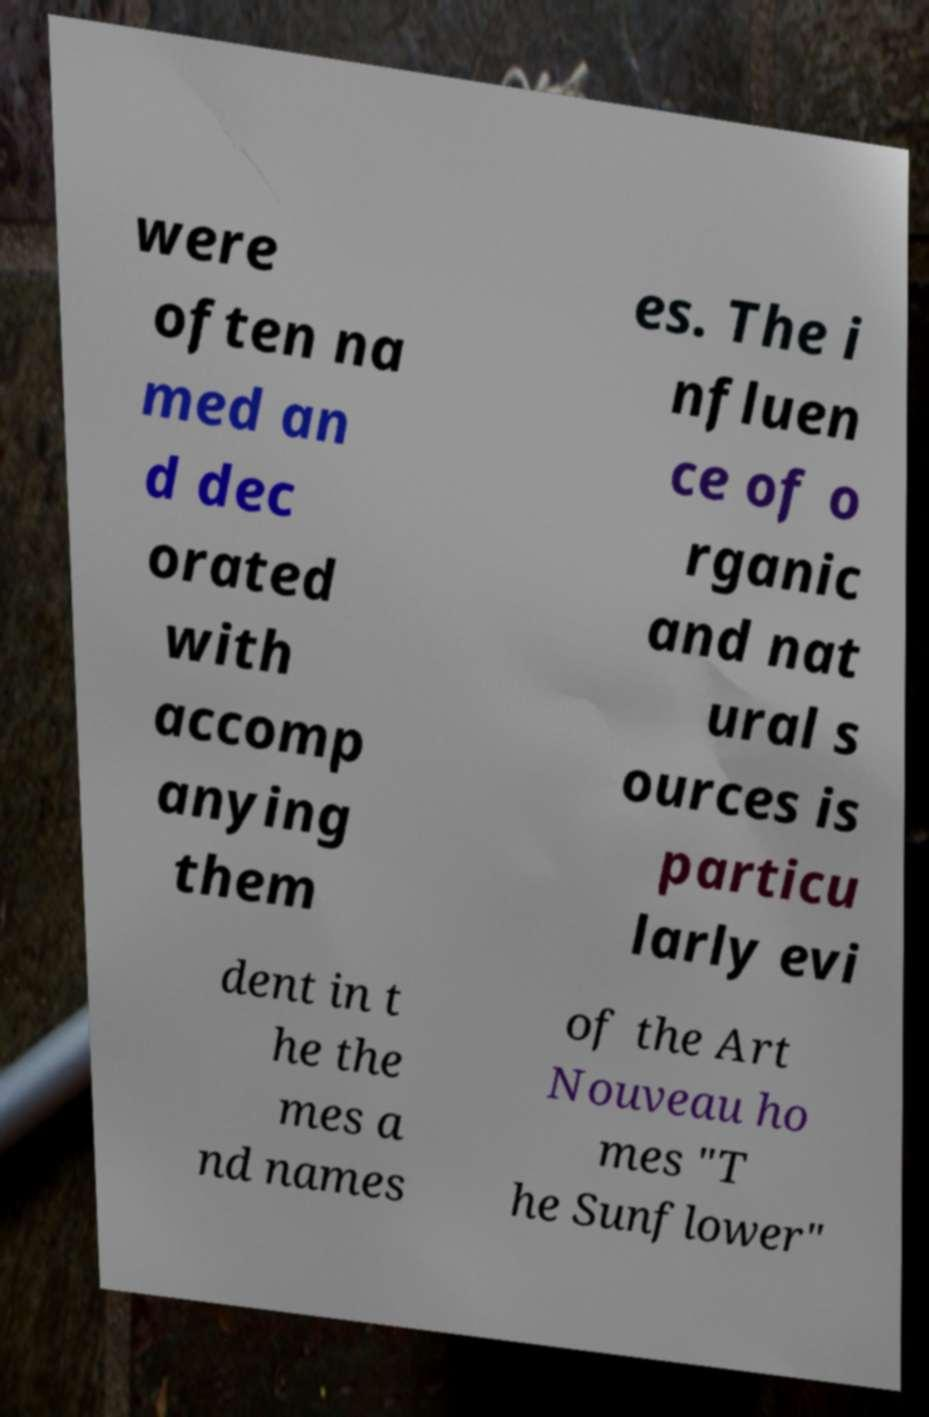What messages or text are displayed in this image? I need them in a readable, typed format. were often na med an d dec orated with accomp anying them es. The i nfluen ce of o rganic and nat ural s ources is particu larly evi dent in t he the mes a nd names of the Art Nouveau ho mes "T he Sunflower" 